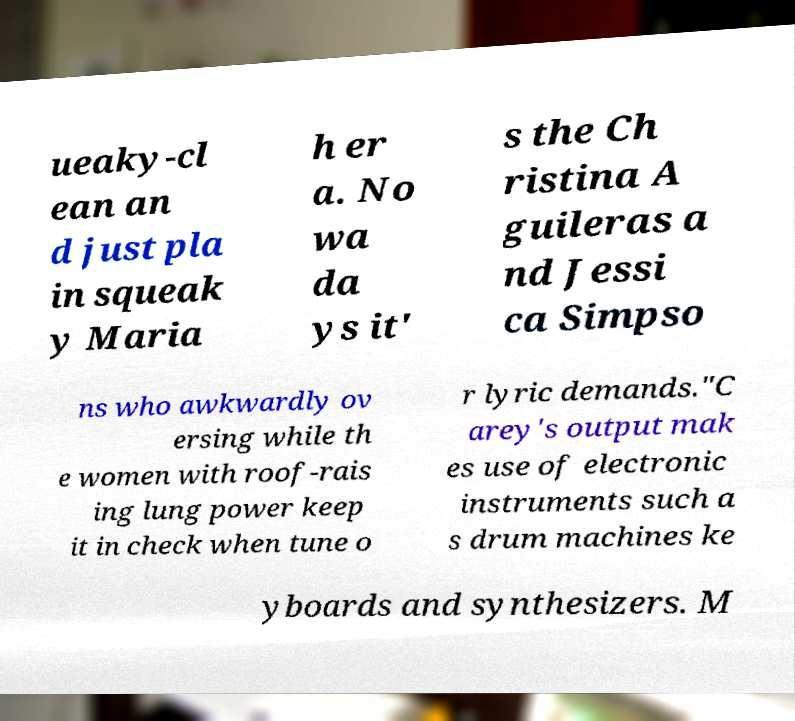Please read and relay the text visible in this image. What does it say? ueaky-cl ean an d just pla in squeak y Maria h er a. No wa da ys it' s the Ch ristina A guileras a nd Jessi ca Simpso ns who awkwardly ov ersing while th e women with roof-rais ing lung power keep it in check when tune o r lyric demands."C arey's output mak es use of electronic instruments such a s drum machines ke yboards and synthesizers. M 